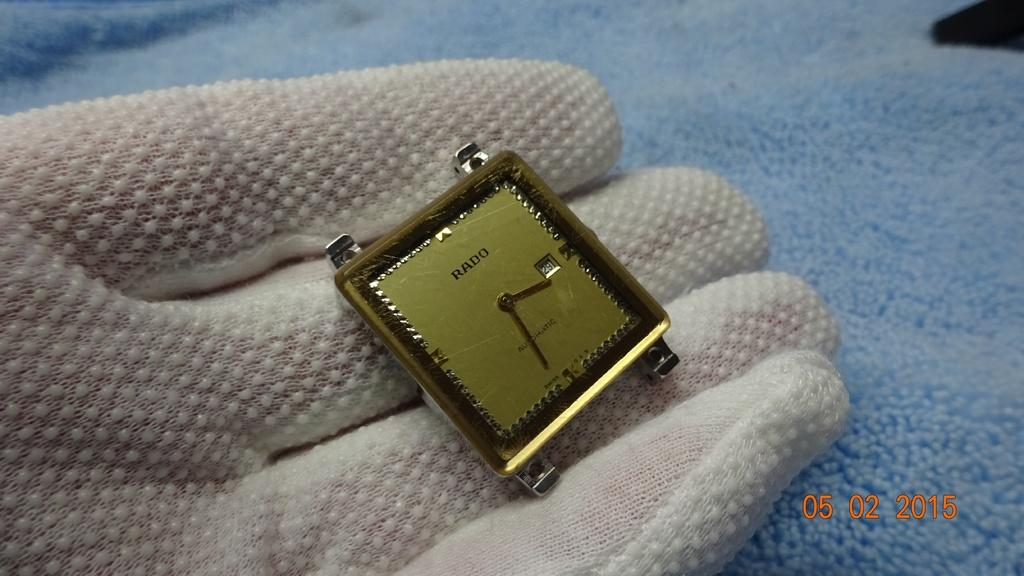Provide a one-sentence caption for the provided image. A beautiful Dial of the golden automatic watch from Rado Company. 